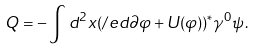Convert formula to latex. <formula><loc_0><loc_0><loc_500><loc_500>Q = - \int d ^ { 2 } x ( \slash e d { \partial } \varphi + U ( \varphi ) ) ^ { * } \gamma ^ { 0 } \psi \, .</formula> 